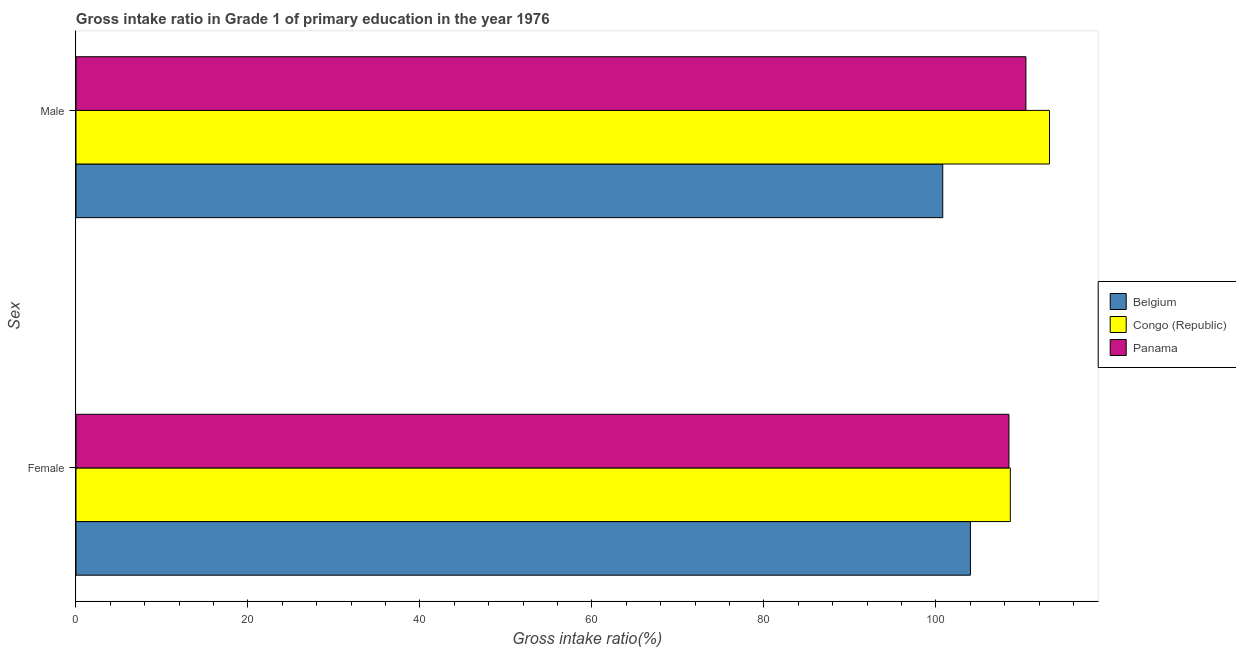How many groups of bars are there?
Make the answer very short. 2. Are the number of bars per tick equal to the number of legend labels?
Provide a succinct answer. Yes. Are the number of bars on each tick of the Y-axis equal?
Provide a short and direct response. Yes. How many bars are there on the 2nd tick from the bottom?
Your answer should be very brief. 3. What is the gross intake ratio(female) in Belgium?
Your answer should be compact. 104.01. Across all countries, what is the maximum gross intake ratio(female)?
Ensure brevity in your answer.  108.65. Across all countries, what is the minimum gross intake ratio(male)?
Keep it short and to the point. 100.79. In which country was the gross intake ratio(male) maximum?
Give a very brief answer. Congo (Republic). What is the total gross intake ratio(male) in the graph?
Give a very brief answer. 324.47. What is the difference between the gross intake ratio(male) in Belgium and that in Panama?
Ensure brevity in your answer.  -9.67. What is the difference between the gross intake ratio(female) in Belgium and the gross intake ratio(male) in Congo (Republic)?
Provide a short and direct response. -9.2. What is the average gross intake ratio(male) per country?
Offer a terse response. 108.16. What is the difference between the gross intake ratio(male) and gross intake ratio(female) in Panama?
Keep it short and to the point. 1.97. What is the ratio of the gross intake ratio(male) in Belgium to that in Congo (Republic)?
Offer a terse response. 0.89. Is the gross intake ratio(female) in Belgium less than that in Congo (Republic)?
Your response must be concise. Yes. In how many countries, is the gross intake ratio(male) greater than the average gross intake ratio(male) taken over all countries?
Your answer should be compact. 2. What does the 1st bar from the top in Male represents?
Your answer should be compact. Panama. What does the 3rd bar from the bottom in Male represents?
Offer a terse response. Panama. How many bars are there?
Your answer should be very brief. 6. Are all the bars in the graph horizontal?
Provide a succinct answer. Yes. What is the difference between two consecutive major ticks on the X-axis?
Ensure brevity in your answer.  20. Are the values on the major ticks of X-axis written in scientific E-notation?
Your answer should be compact. No. Does the graph contain any zero values?
Your answer should be compact. No. How many legend labels are there?
Ensure brevity in your answer.  3. What is the title of the graph?
Provide a short and direct response. Gross intake ratio in Grade 1 of primary education in the year 1976. What is the label or title of the X-axis?
Offer a very short reply. Gross intake ratio(%). What is the label or title of the Y-axis?
Keep it short and to the point. Sex. What is the Gross intake ratio(%) in Belgium in Female?
Offer a very short reply. 104.01. What is the Gross intake ratio(%) of Congo (Republic) in Female?
Ensure brevity in your answer.  108.65. What is the Gross intake ratio(%) in Panama in Female?
Offer a terse response. 108.49. What is the Gross intake ratio(%) of Belgium in Male?
Provide a succinct answer. 100.79. What is the Gross intake ratio(%) of Congo (Republic) in Male?
Make the answer very short. 113.21. What is the Gross intake ratio(%) of Panama in Male?
Provide a succinct answer. 110.46. Across all Sex, what is the maximum Gross intake ratio(%) of Belgium?
Your response must be concise. 104.01. Across all Sex, what is the maximum Gross intake ratio(%) in Congo (Republic)?
Offer a very short reply. 113.21. Across all Sex, what is the maximum Gross intake ratio(%) in Panama?
Your response must be concise. 110.46. Across all Sex, what is the minimum Gross intake ratio(%) of Belgium?
Make the answer very short. 100.79. Across all Sex, what is the minimum Gross intake ratio(%) in Congo (Republic)?
Your answer should be very brief. 108.65. Across all Sex, what is the minimum Gross intake ratio(%) of Panama?
Provide a short and direct response. 108.49. What is the total Gross intake ratio(%) in Belgium in the graph?
Offer a very short reply. 204.8. What is the total Gross intake ratio(%) in Congo (Republic) in the graph?
Keep it short and to the point. 221.86. What is the total Gross intake ratio(%) of Panama in the graph?
Your answer should be compact. 218.95. What is the difference between the Gross intake ratio(%) of Belgium in Female and that in Male?
Your answer should be compact. 3.22. What is the difference between the Gross intake ratio(%) of Congo (Republic) in Female and that in Male?
Give a very brief answer. -4.56. What is the difference between the Gross intake ratio(%) of Panama in Female and that in Male?
Offer a terse response. -1.97. What is the difference between the Gross intake ratio(%) of Belgium in Female and the Gross intake ratio(%) of Congo (Republic) in Male?
Provide a short and direct response. -9.2. What is the difference between the Gross intake ratio(%) of Belgium in Female and the Gross intake ratio(%) of Panama in Male?
Give a very brief answer. -6.45. What is the difference between the Gross intake ratio(%) in Congo (Republic) in Female and the Gross intake ratio(%) in Panama in Male?
Provide a short and direct response. -1.81. What is the average Gross intake ratio(%) in Belgium per Sex?
Offer a very short reply. 102.4. What is the average Gross intake ratio(%) of Congo (Republic) per Sex?
Your answer should be compact. 110.93. What is the average Gross intake ratio(%) in Panama per Sex?
Make the answer very short. 109.48. What is the difference between the Gross intake ratio(%) of Belgium and Gross intake ratio(%) of Congo (Republic) in Female?
Your response must be concise. -4.64. What is the difference between the Gross intake ratio(%) in Belgium and Gross intake ratio(%) in Panama in Female?
Your answer should be compact. -4.48. What is the difference between the Gross intake ratio(%) in Congo (Republic) and Gross intake ratio(%) in Panama in Female?
Make the answer very short. 0.16. What is the difference between the Gross intake ratio(%) in Belgium and Gross intake ratio(%) in Congo (Republic) in Male?
Provide a short and direct response. -12.42. What is the difference between the Gross intake ratio(%) in Belgium and Gross intake ratio(%) in Panama in Male?
Ensure brevity in your answer.  -9.67. What is the difference between the Gross intake ratio(%) in Congo (Republic) and Gross intake ratio(%) in Panama in Male?
Keep it short and to the point. 2.74. What is the ratio of the Gross intake ratio(%) in Belgium in Female to that in Male?
Offer a very short reply. 1.03. What is the ratio of the Gross intake ratio(%) in Congo (Republic) in Female to that in Male?
Offer a terse response. 0.96. What is the ratio of the Gross intake ratio(%) in Panama in Female to that in Male?
Offer a very short reply. 0.98. What is the difference between the highest and the second highest Gross intake ratio(%) in Belgium?
Provide a short and direct response. 3.22. What is the difference between the highest and the second highest Gross intake ratio(%) in Congo (Republic)?
Your answer should be compact. 4.56. What is the difference between the highest and the second highest Gross intake ratio(%) in Panama?
Give a very brief answer. 1.97. What is the difference between the highest and the lowest Gross intake ratio(%) of Belgium?
Your response must be concise. 3.22. What is the difference between the highest and the lowest Gross intake ratio(%) of Congo (Republic)?
Your answer should be compact. 4.56. What is the difference between the highest and the lowest Gross intake ratio(%) in Panama?
Make the answer very short. 1.97. 